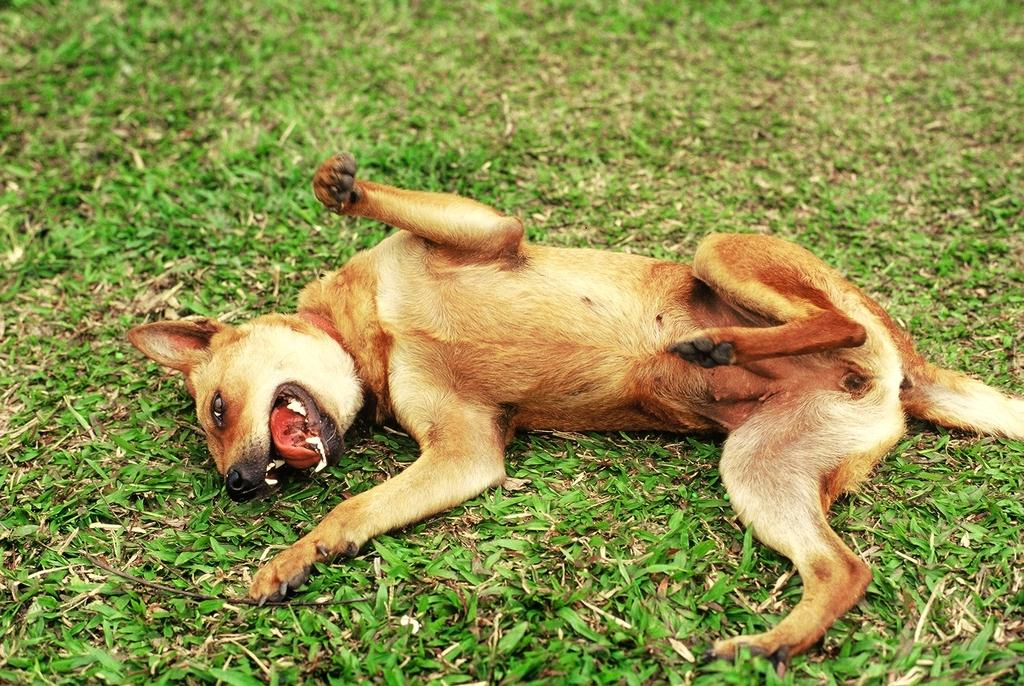What is the main subject in the center of the image? There is a dog in the center of the image. What type of surface is visible at the bottom of the image? There is grass at the bottom of the image. What type of machine can be seen in the background of the image? There is no machine present in the image; it features a dog and grass. What type of clothing accessory is visible on the dog in the image? There is no clothing accessory, such as lace, present on the dog in the image. 